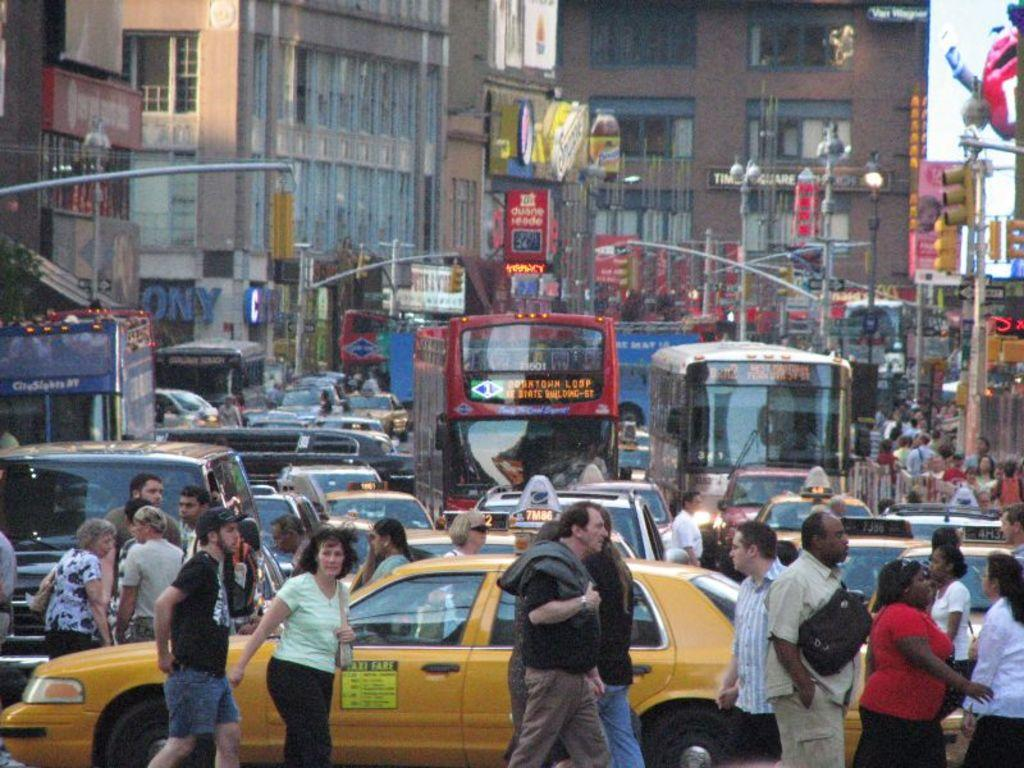Provide a one-sentence caption for the provided image. In a busy street, the yellow cab has a sign on the side of the door explaining the fare prices. 